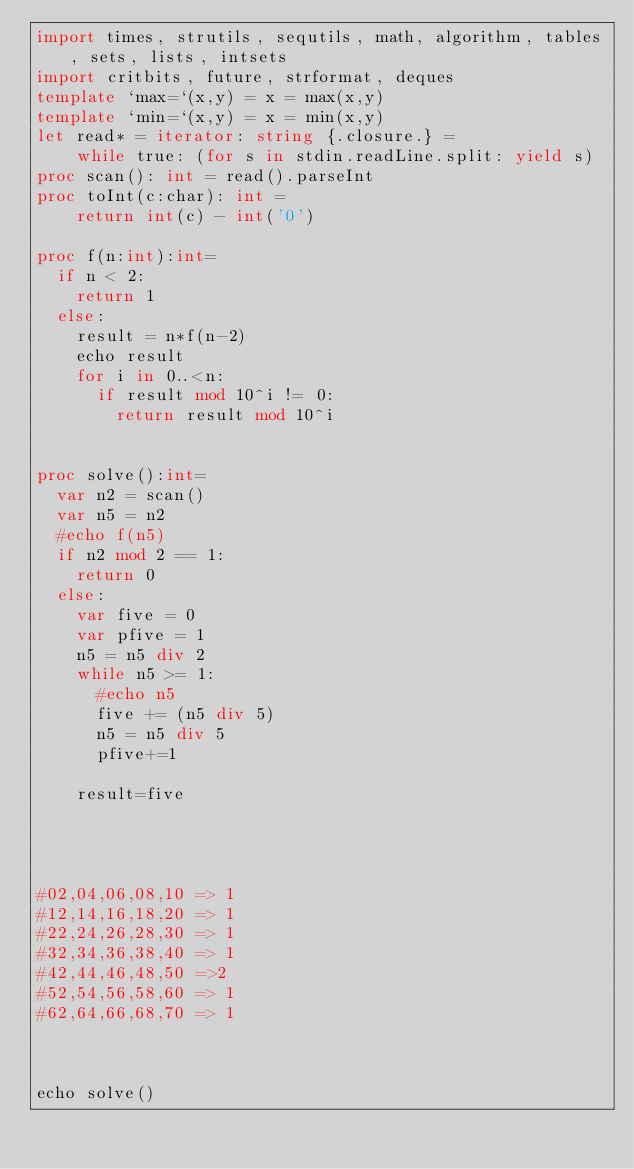<code> <loc_0><loc_0><loc_500><loc_500><_Nim_>import times, strutils, sequtils, math, algorithm, tables, sets, lists, intsets
import critbits, future, strformat, deques
template `max=`(x,y) = x = max(x,y)
template `min=`(x,y) = x = min(x,y)
let read* = iterator: string {.closure.} =
    while true: (for s in stdin.readLine.split: yield s)
proc scan(): int = read().parseInt
proc toInt(c:char): int =
    return int(c) - int('0')

proc f(n:int):int=
  if n < 2:
    return 1
  else:
    result = n*f(n-2)
    echo result
    for i in 0..<n:
      if result mod 10^i != 0:
        return result mod 10^i
    

proc solve():int=
  var n2 = scan()
  var n5 = n2
  #echo f(n5)
  if n2 mod 2 == 1:
    return 0
  else:
    var five = 0
    var pfive = 1
    n5 = n5 div 2
    while n5 >= 1:
      #echo n5
      five += (n5 div 5)
      n5 = n5 div 5
      pfive+=1
    
    result=five

  
    

#02,04,06,08,10 => 1
#12,14,16,18,20 => 1
#22,24,26,28,30 => 1
#32,34,36,38,40 => 1
#42,44,46,48,50 =>2  
#52,54,56,58,60 => 1   
#62,64,66,68,70 => 1 



echo solve()</code> 